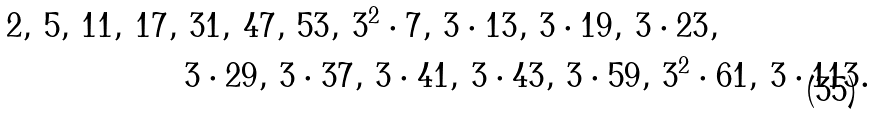Convert formula to latex. <formula><loc_0><loc_0><loc_500><loc_500>2 , \, 5 , \, 1 1 , \, 1 7 , \, & \, 3 1 , \, 4 7 , \, 5 3 , \, 3 ^ { 2 } \cdot 7 , \, 3 \cdot 1 3 , \, 3 \cdot 1 9 , \, 3 \cdot 2 3 , \, \\ & 3 \cdot 2 9 , \, 3 \cdot 3 7 , \, 3 \cdot 4 1 , \, 3 \cdot 4 3 , \, 3 \cdot 5 9 , \, 3 ^ { 2 } \cdot 6 1 , \, 3 \cdot 1 1 3 .</formula> 